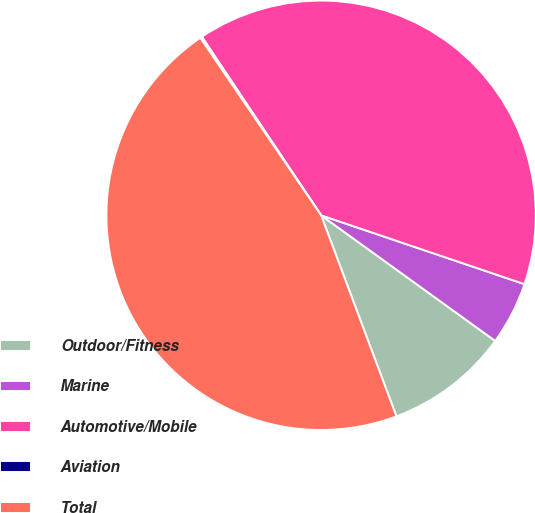Convert chart. <chart><loc_0><loc_0><loc_500><loc_500><pie_chart><fcel>Outdoor/Fitness<fcel>Marine<fcel>Automotive/Mobile<fcel>Aviation<fcel>Total<nl><fcel>9.35%<fcel>4.75%<fcel>39.57%<fcel>0.14%<fcel>46.19%<nl></chart> 